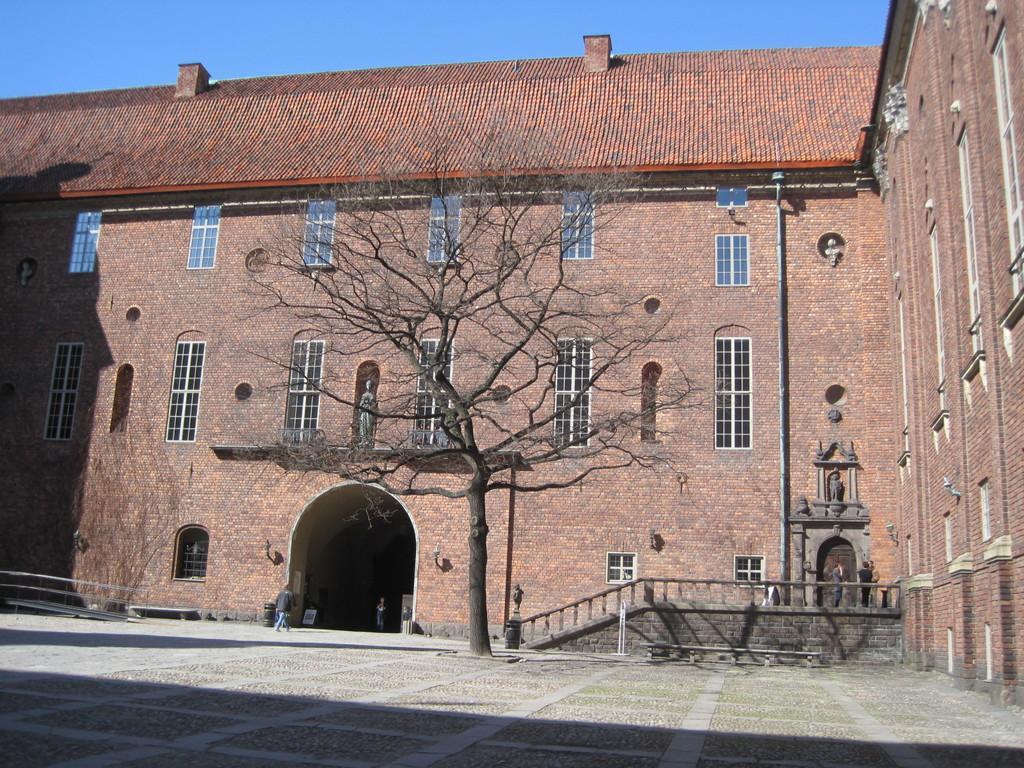In one or two sentences, can you explain what this image depicts? There is a man walking and we can see building,tree,windows and statues. In the background we can see sky in blue color. 